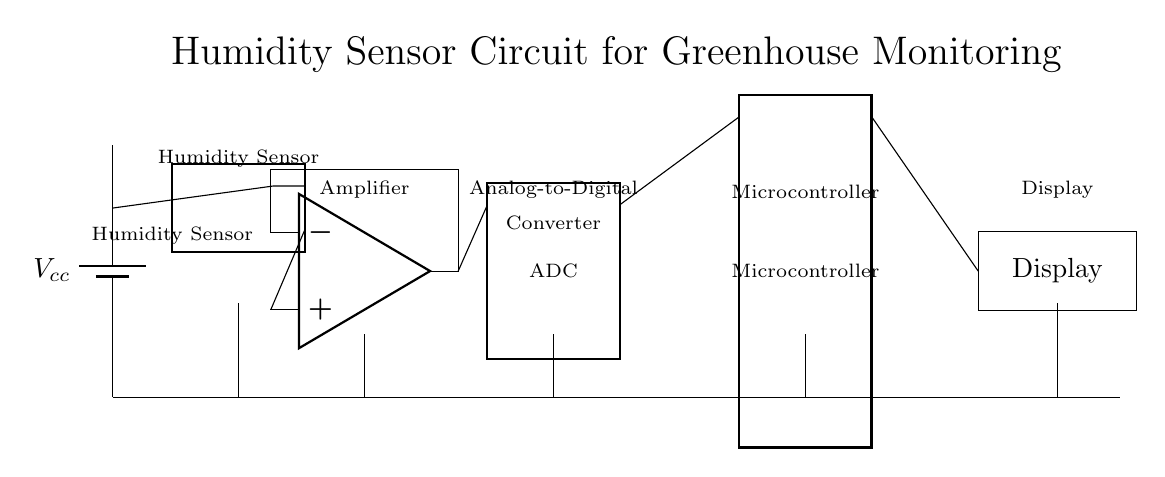What is the main function of the humidity sensor? The main function of the humidity sensor is to detect and measure the humidity levels in the greenhouse. This is indicated by its labeling in the circuit diagram.
Answer: Humidity measurement What component connects the humidity sensor to the amplifier? The connection between the humidity sensor and the amplifier is made through a wire that directly links the output pin of the humidity sensor to the input of the amplifier. This is visually represented in the circuit diagram.
Answer: Wire How many pins does the microcontroller have? The microcontroller is depicted as having 16 pins, which can be counted directly from the diagram.
Answer: Sixteen pins What device is used to convert the analog signal from the amplifier? The device used to convert the analog signal into a digital format is the Analog-to-Digital Converter, as explicitly labeled in the circuit diagram.
Answer: ADC How is the display connected to the microcontroller? The display is connected to the microcontroller through its 16th pin, which is illustrated with a direct line in the circuit drawing connecting the two components.
Answer: Through pin sixteen What is the role of the amplifier in this circuit? The amplifier's role is to boost the signal received from the humidity sensor before it is sent to the analog-to-digital converter. This is determined by its position in the signal path within the circuit.
Answer: Signal amplification Which component powers the entire circuit? The circuit is powered by the battery labeled as Vcc, which provides the necessary voltage for all components in the circuit. This is clearly indicated in the diagram.
Answer: Battery 